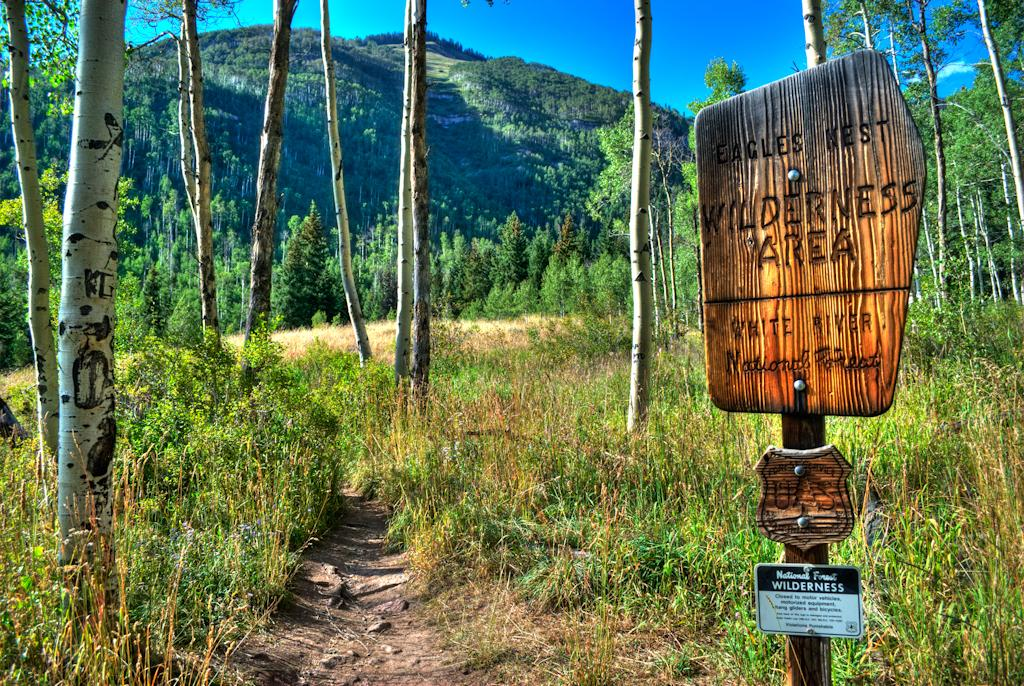What type of landscape is depicted in the image? There is a field in the image. What can be found within the field? There are trees in the field. What is visible in the distance behind the field? There is a mountain in the background of the image. What color is the sky in the image? The sky is blue in the image. How many calculators can be seen in the field? There are no calculators present in the image; it features a field with trees and a mountain in the background. What type of fowl is perched on the mountain in the image? There are no fowl visible in the image; the mountain is in the background without any animals or birds present. 